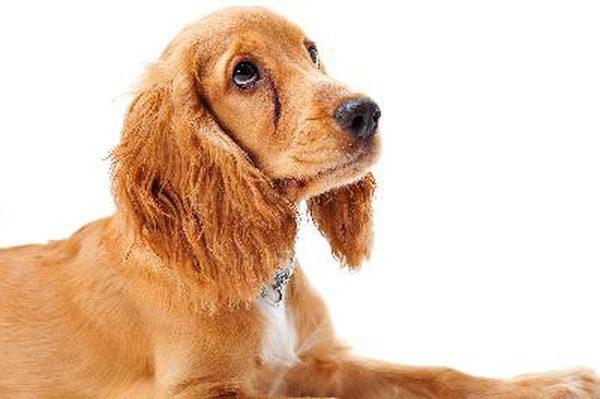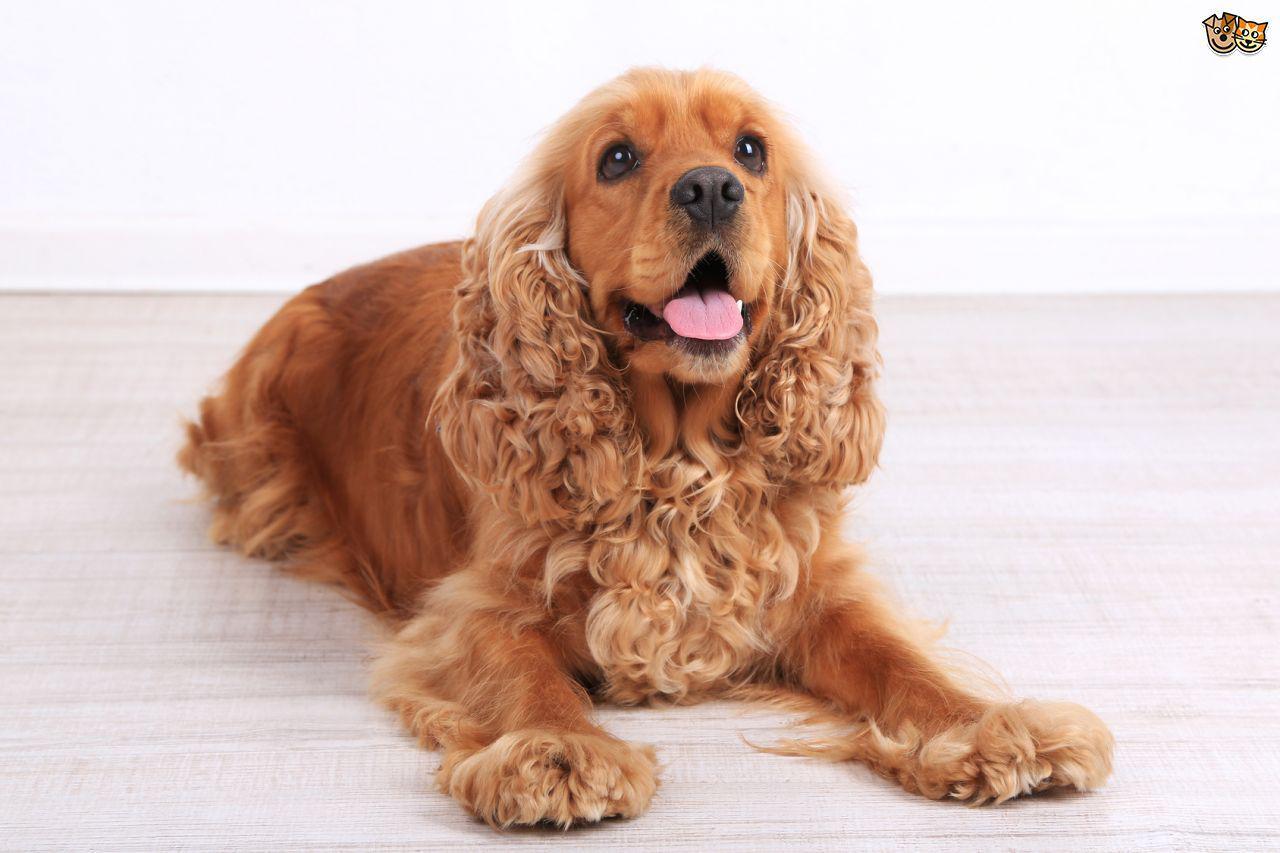The first image is the image on the left, the second image is the image on the right. Assess this claim about the two images: "The right image shows a young puppy.". Correct or not? Answer yes or no. No. 